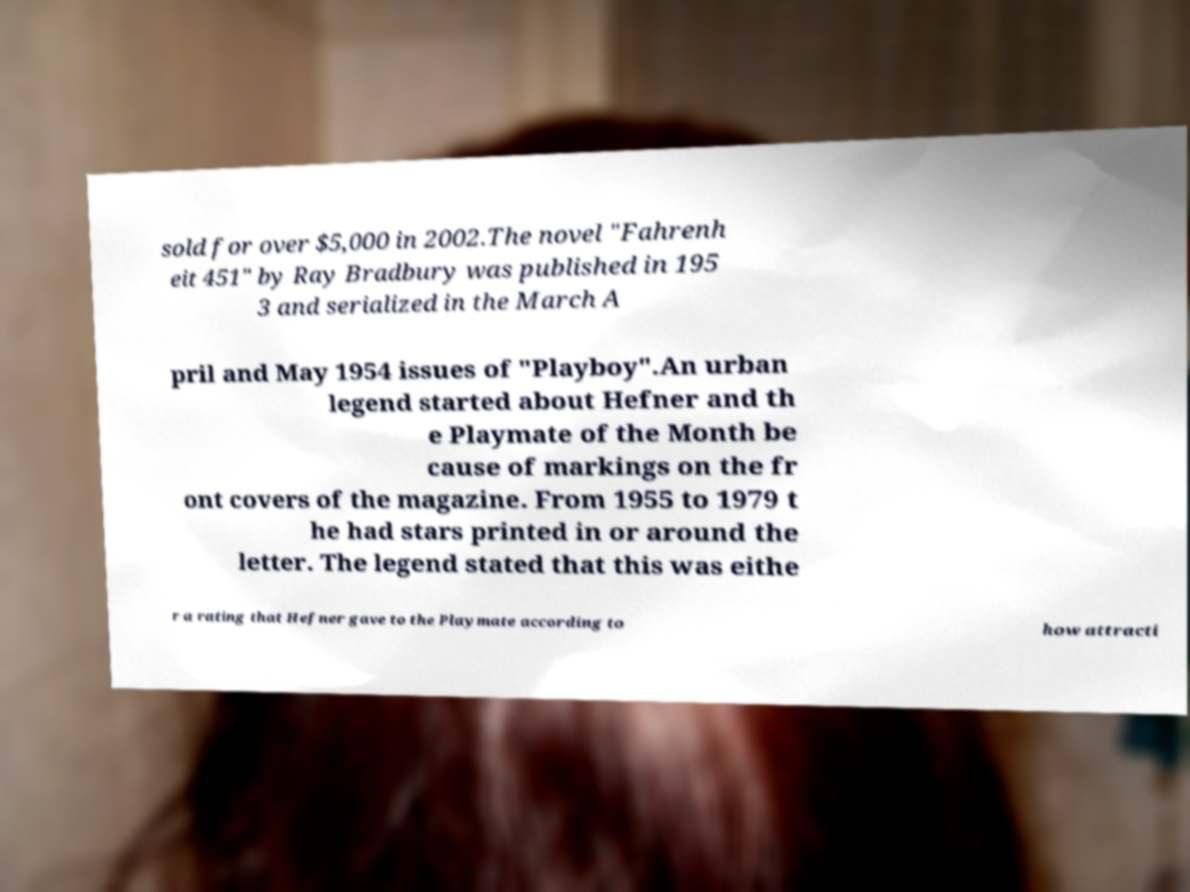Can you accurately transcribe the text from the provided image for me? sold for over $5,000 in 2002.The novel "Fahrenh eit 451" by Ray Bradbury was published in 195 3 and serialized in the March A pril and May 1954 issues of "Playboy".An urban legend started about Hefner and th e Playmate of the Month be cause of markings on the fr ont covers of the magazine. From 1955 to 1979 t he had stars printed in or around the letter. The legend stated that this was eithe r a rating that Hefner gave to the Playmate according to how attracti 